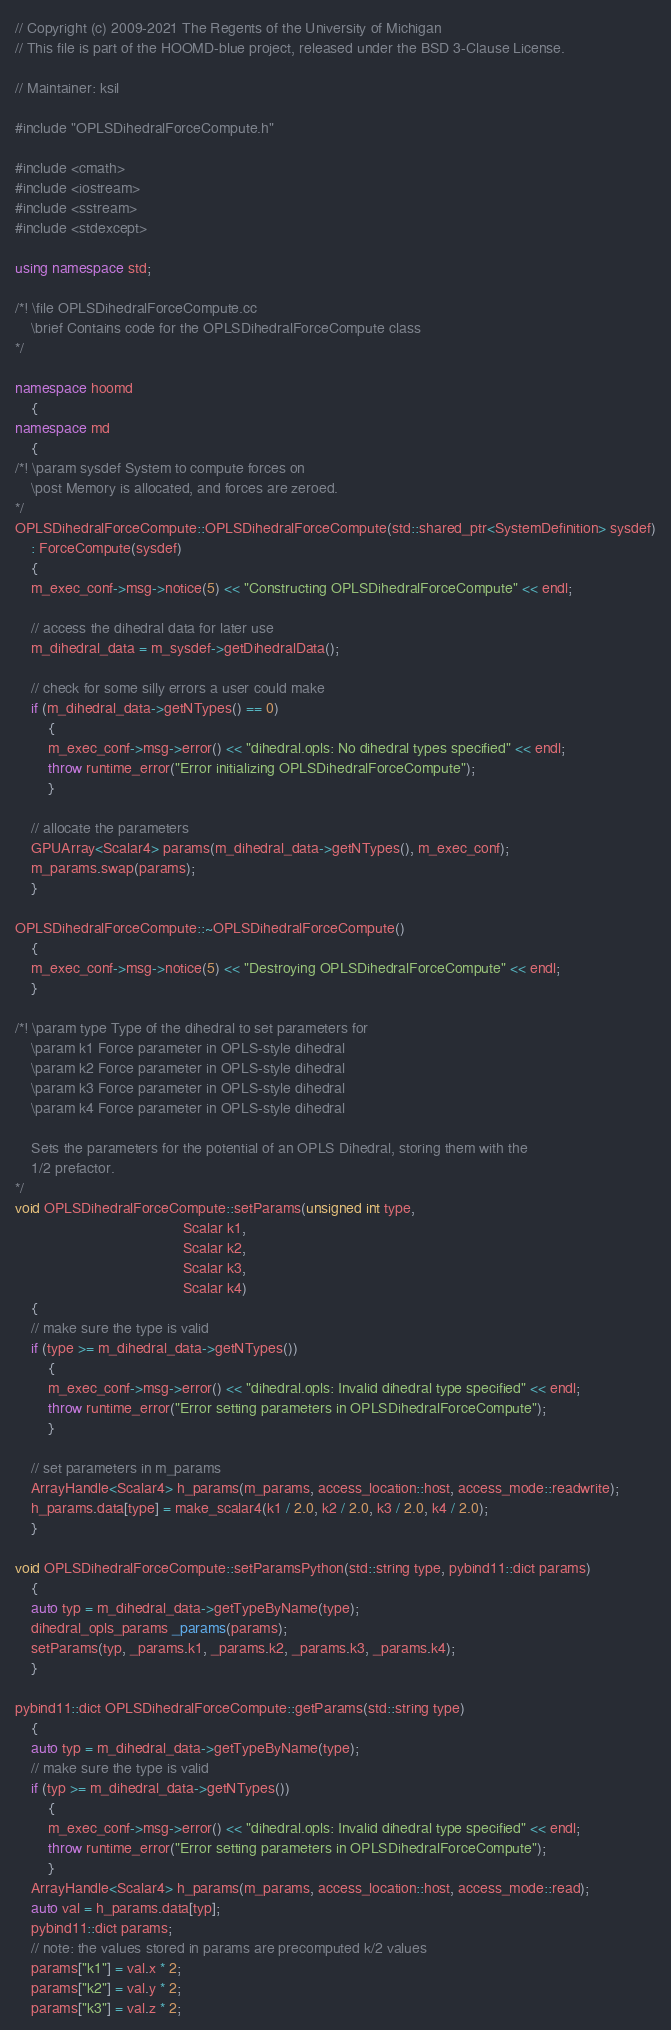<code> <loc_0><loc_0><loc_500><loc_500><_C++_>// Copyright (c) 2009-2021 The Regents of the University of Michigan
// This file is part of the HOOMD-blue project, released under the BSD 3-Clause License.

// Maintainer: ksil

#include "OPLSDihedralForceCompute.h"

#include <cmath>
#include <iostream>
#include <sstream>
#include <stdexcept>

using namespace std;

/*! \file OPLSDihedralForceCompute.cc
    \brief Contains code for the OPLSDihedralForceCompute class
*/

namespace hoomd
    {
namespace md
    {
/*! \param sysdef System to compute forces on
    \post Memory is allocated, and forces are zeroed.
*/
OPLSDihedralForceCompute::OPLSDihedralForceCompute(std::shared_ptr<SystemDefinition> sysdef)
    : ForceCompute(sysdef)
    {
    m_exec_conf->msg->notice(5) << "Constructing OPLSDihedralForceCompute" << endl;

    // access the dihedral data for later use
    m_dihedral_data = m_sysdef->getDihedralData();

    // check for some silly errors a user could make
    if (m_dihedral_data->getNTypes() == 0)
        {
        m_exec_conf->msg->error() << "dihedral.opls: No dihedral types specified" << endl;
        throw runtime_error("Error initializing OPLSDihedralForceCompute");
        }

    // allocate the parameters
    GPUArray<Scalar4> params(m_dihedral_data->getNTypes(), m_exec_conf);
    m_params.swap(params);
    }

OPLSDihedralForceCompute::~OPLSDihedralForceCompute()
    {
    m_exec_conf->msg->notice(5) << "Destroying OPLSDihedralForceCompute" << endl;
    }

/*! \param type Type of the dihedral to set parameters for
    \param k1 Force parameter in OPLS-style dihedral
    \param k2 Force parameter in OPLS-style dihedral
    \param k3 Force parameter in OPLS-style dihedral
    \param k4 Force parameter in OPLS-style dihedral

    Sets the parameters for the potential of an OPLS Dihedral, storing them with the
    1/2 prefactor.
*/
void OPLSDihedralForceCompute::setParams(unsigned int type,
                                         Scalar k1,
                                         Scalar k2,
                                         Scalar k3,
                                         Scalar k4)
    {
    // make sure the type is valid
    if (type >= m_dihedral_data->getNTypes())
        {
        m_exec_conf->msg->error() << "dihedral.opls: Invalid dihedral type specified" << endl;
        throw runtime_error("Error setting parameters in OPLSDihedralForceCompute");
        }

    // set parameters in m_params
    ArrayHandle<Scalar4> h_params(m_params, access_location::host, access_mode::readwrite);
    h_params.data[type] = make_scalar4(k1 / 2.0, k2 / 2.0, k3 / 2.0, k4 / 2.0);
    }

void OPLSDihedralForceCompute::setParamsPython(std::string type, pybind11::dict params)
    {
    auto typ = m_dihedral_data->getTypeByName(type);
    dihedral_opls_params _params(params);
    setParams(typ, _params.k1, _params.k2, _params.k3, _params.k4);
    }

pybind11::dict OPLSDihedralForceCompute::getParams(std::string type)
    {
    auto typ = m_dihedral_data->getTypeByName(type);
    // make sure the type is valid
    if (typ >= m_dihedral_data->getNTypes())
        {
        m_exec_conf->msg->error() << "dihedral.opls: Invalid dihedral type specified" << endl;
        throw runtime_error("Error setting parameters in OPLSDihedralForceCompute");
        }
    ArrayHandle<Scalar4> h_params(m_params, access_location::host, access_mode::read);
    auto val = h_params.data[typ];
    pybind11::dict params;
    // note: the values stored in params are precomputed k/2 values
    params["k1"] = val.x * 2;
    params["k2"] = val.y * 2;
    params["k3"] = val.z * 2;</code> 